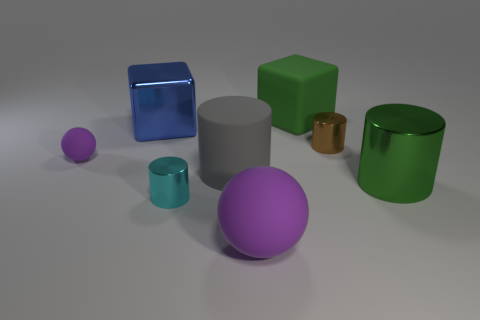Add 1 brown blocks. How many objects exist? 9 Subtract all cubes. How many objects are left? 6 Add 2 rubber cylinders. How many rubber cylinders are left? 3 Add 8 large green matte cubes. How many large green matte cubes exist? 9 Subtract 0 red cylinders. How many objects are left? 8 Subtract all purple matte cubes. Subtract all small purple objects. How many objects are left? 7 